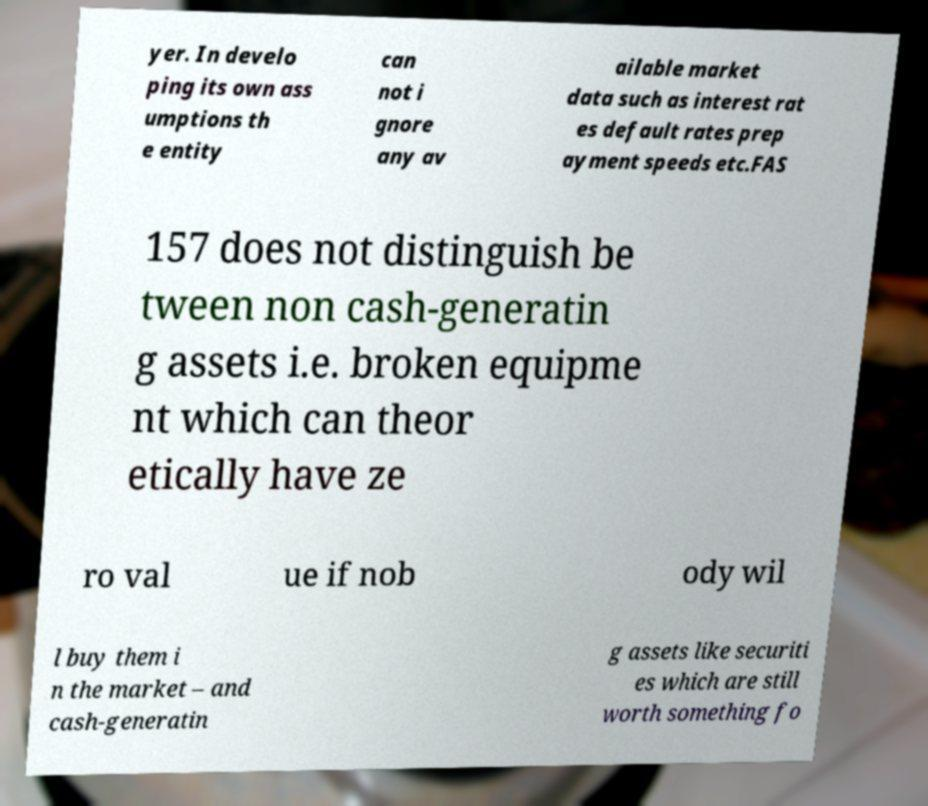There's text embedded in this image that I need extracted. Can you transcribe it verbatim? yer. In develo ping its own ass umptions th e entity can not i gnore any av ailable market data such as interest rat es default rates prep ayment speeds etc.FAS 157 does not distinguish be tween non cash-generatin g assets i.e. broken equipme nt which can theor etically have ze ro val ue if nob ody wil l buy them i n the market – and cash-generatin g assets like securiti es which are still worth something fo 